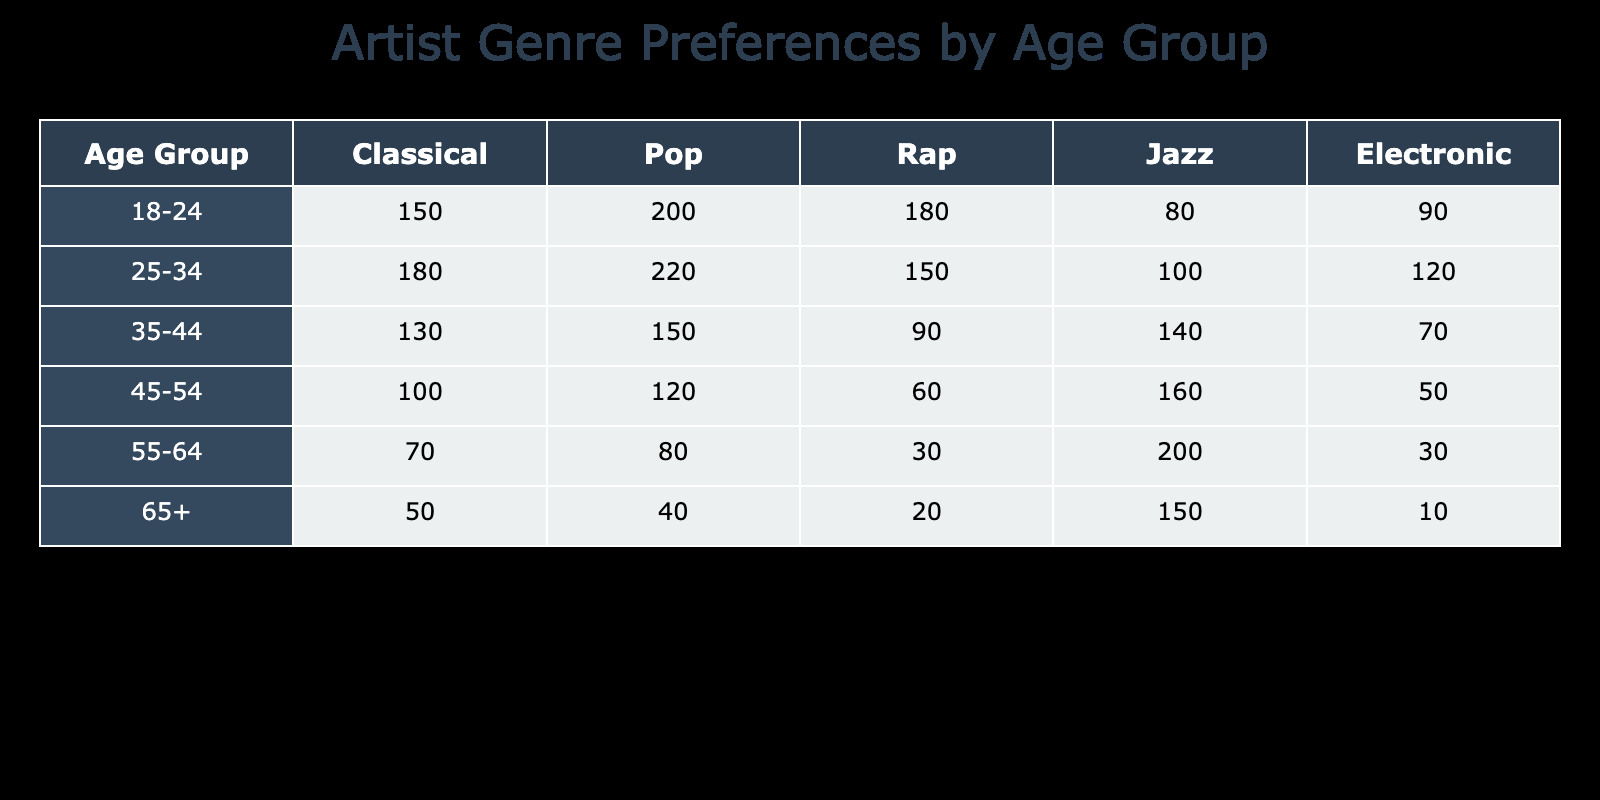What age group has the highest preference for Jazz music? By reviewing the 'Jazz' column, the highest value is 200, which is in the 55-64 age group.
Answer: 55-64 What is the total preference for Electronic music across all age groups? To find the total preference for Electronic music, we sum up all the values in the Electronic column: 90 + 120 + 70 + 50 + 30 + 10 = 370.
Answer: 370 Is the preference for Classical music higher in the 25-34 age group compared to the 35-44 age group? The preference for Classical music in the 25-34 age group is 180, while in the 35-44 age group it is 130. Since 180 > 130, this statement is true.
Answer: Yes What is the average preference for Pop music across all age groups? To compute the average for Pop music, sum the values: 200 + 220 + 150 + 120 + 80 + 40 = 810. There are 6 age groups, so the average is 810/6 = 135.
Answer: 135 Which age group shows the least preference for Rap music? Looking at the Rap column, the least value is 20, which is associated with the 65+ age group.
Answer: 65+ What is the difference between the total preference for Classical music and Pop music among the 45-54 age group? In the 45-54 age group, the preference for Classical is 100 and for Pop is 120. The difference is 120 - 100 = 20.
Answer: 20 Do more people aged 18-24 prefer Pop or Rap music? The preference for Pop among 18-24 is 200 and for Rap is 180. Since 200 > 180, more people in this age group prefer Pop music.
Answer: Pop What is the total preference for Jazz and Electronic music among the 35-44 age group? For the 35-44 age group, the preference for Jazz is 140, and for Electronic, it is 70. The total preference is 140 + 70 = 210.
Answer: 210 What age group has the second highest preference for Classical music? Reviewing the Classical column, the highest is 180 (25-34), and the second highest is 150 (18-24).
Answer: 18-24 